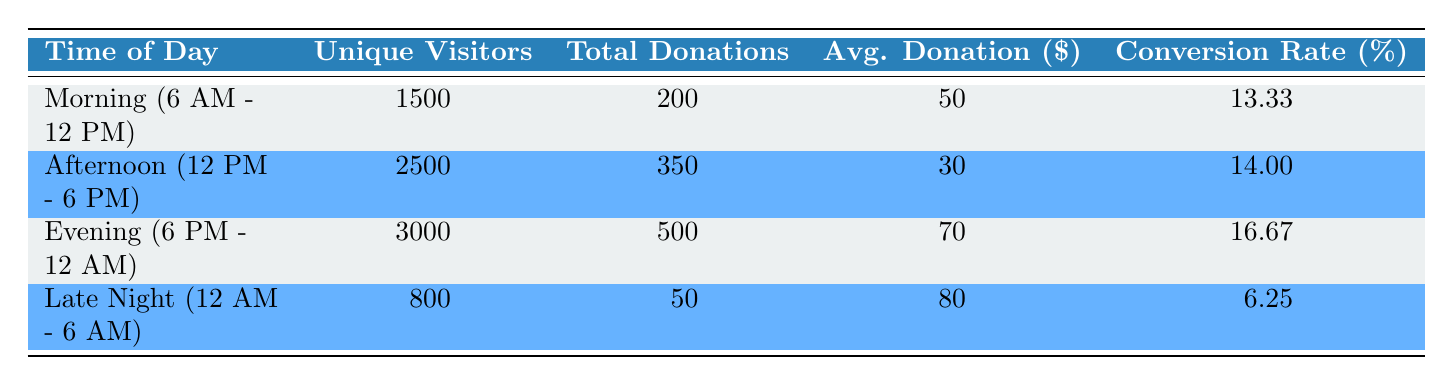What is the unique number of visitors in the Evening? The table indicates that during the Evening (6 PM - 12 AM), there are 3000 unique visitors listed.
Answer: 3000 Which time of day has the highest average donation amount? The average donation amounts listed for each time of day are as follows: Morning (50), Afternoon (30), Evening (70), and Late Night (80). The highest value among these is 80, corresponding to Late Night (12 AM - 6 AM).
Answer: Late Night What is the total number of donations made during the Afternoon? The table shows that the total donations made in the Afternoon (12 PM - 6 PM) is 350, as directly stated in the respective row.
Answer: 350 Is the conversion rate higher in the Morning than in the Late Night? The conversion rates are 13.33 percent for the Morning and 6.25 percent for Late Night. Since 13.33 is greater than 6.25, it confirms that the conversion rate in the Morning is indeed higher.
Answer: Yes What is the total number of unique visitors across all time periods? To find the total unique visitors, we sum the figures from each time period: 1500 (Morning) + 2500 (Afternoon) + 3000 (Evening) + 800 (Late Night) = 7800 unique visitors.
Answer: 7800 What is the difference in conversion rates between the Evening and the Afternoon? The conversion rates are 16.67 percent for Evening and 14.00 percent for Afternoon. The difference is 16.67 - 14.00 = 2.67 percent.
Answer: 2.67 Which time period has the lowest total donations? The total donations listed for each time period are 200 (Morning), 350 (Afternoon), 500 (Evening), and 50 (Late Night). The lowest figure is 50, associated with Late Night.
Answer: Late Night Are there more unique visitors during the Afternoon than the Late Night? The total unique visitors are 2500 for the Afternoon and 800 for the Late Night. Since 2500 is more than 800, this indicates more visitors in the Afternoon.
Answer: Yes What is the average donation amount across all time periods? To calculate the average donation amount, we multiply the total donations by their respective average amounts for each time period: (200*50 + 350*30 + 500*70 + 50*80) / (200 + 350 + 500 + 50) = 55.66. This means the average is around 55.66.
Answer: 55.66 